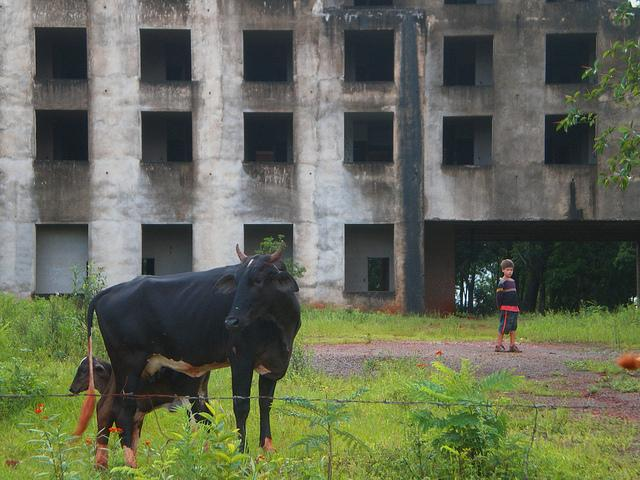What animals is the child looking at? Please explain your reasoning. cows. The kid looks at cows. 